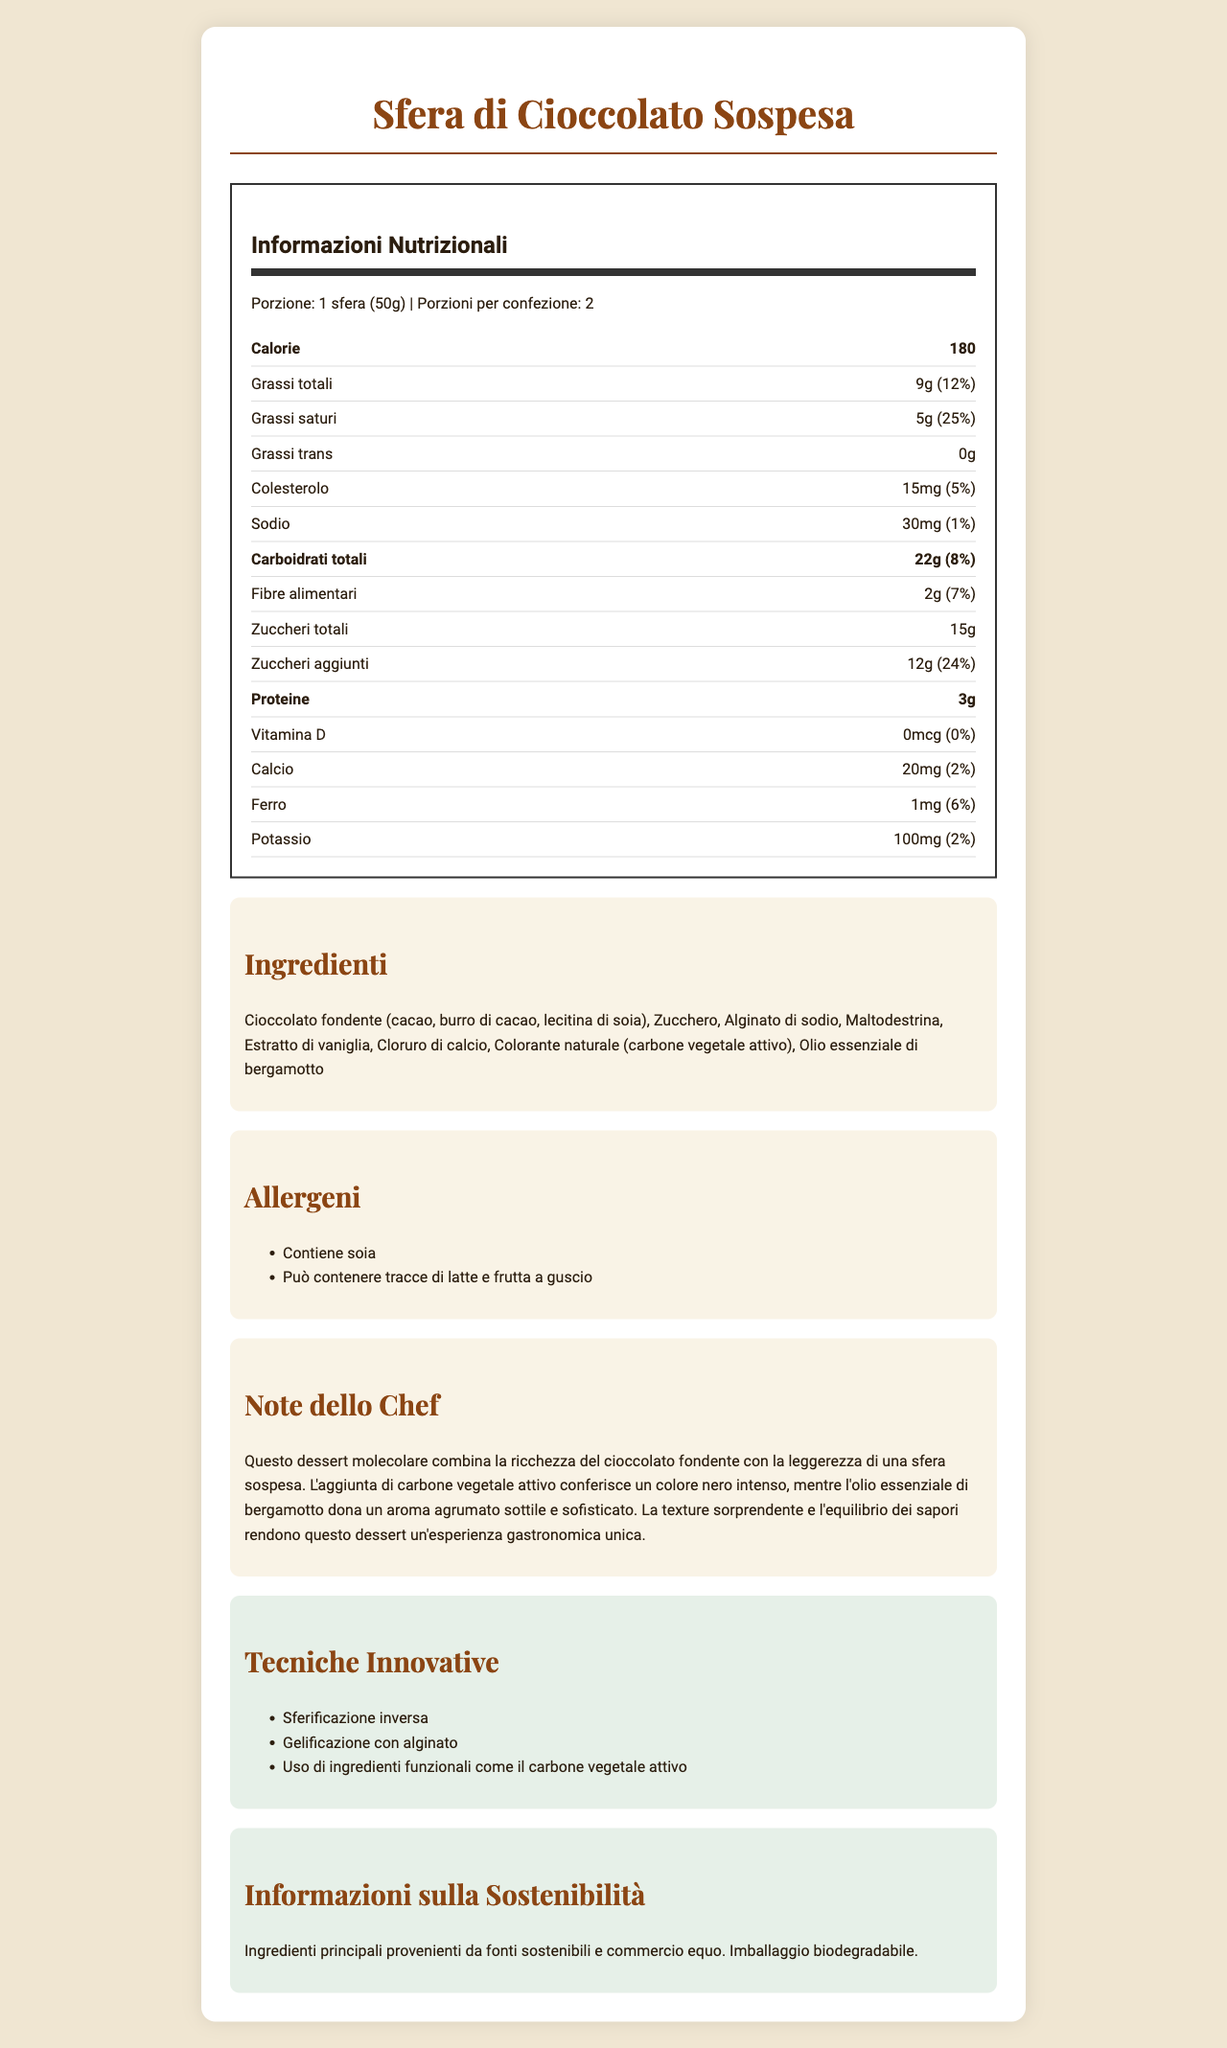what is the serving size for Sfera di Cioccolato Sospesa? The serving size is clearly specified in the nutrition label under the section with the title "Informazioni Nutrizionali".
Answer: 1 sfera (50g) how many servings are in one container? The document states "Porzioni per confezione: 2" in the nutrition information section.
Answer: 2 what is the total amount of calories per serving? The calories per serving are listed as "Calorie 180" in the nutrition label.
Answer: 180 calories what percentage of the daily value of saturated fat does one serving contain? Under the "Grassi saturi" section, it states "5g (25%)" indicating the daily value percentage.
Answer: 25% what innovative techniques are used in the creation of this dessert? The innovative techniques are listed under the "Tecniche Innovative" section.
Answer: Sferificazione inversa, Gelificazione con alginato, Uso di ingredienti funzionali come il carbone vegetale attivo which ingredient is responsible for the black color of the dessert? A. Cioccolato fondente B. Carbone vegetale attivo C. Alginato di sodio D. Maltodestrina The chef's notes mention that the "carbone vegetale attivo" gives an intense black color.
Answer: B what allergens are present in the dessert? The allergens are clearly listed under the "Allergeni" section.
Answer: Contiene soia, Può contenere tracce di latte e frutta a guscio is there any trans fat in this dessert? The nutrition label under the "Grassi trans" section indicates "0g".
Answer: No how much calcium does one serving provide? The amount of calcium is found in the nutrition label under the section "Calcio", specifying "20mg (2%)".
Answer: 20 mg summarize the key aspects of this dessert. This summary captures the main content of the document which includes the name and type of dessert, its unique features, innovative techniques, ingredients, nutritional facts, sustainability information, and allergens.
Answer: Sfera di Cioccolato Sospesa is a molecular dessert that features a rich dark chocolate sphere suspended using molecular gastronomy techniques like inverse spherification and alginate gelling. It integrates innovative ingredients like activated charcoal for a striking black color and bergamot essential oil for a subtle citrus aroma. It contains 180 calories per serving with nutritional information outlined for fats, carbohydrates, and proteins. It is also sustainably sourced and packaged. Allergens include soy, and it may contain traces of milk and nuts. how much protein does one serving contain? The nutrition label under "Proteine" indicates "3g".
Answer: 3 grams does this dessert contain dietary fiber? A. Yes, 2g per serving B. No, 0g per serving C. Yes, 5g per serving D. No, 3g per serving The nutrition label specifies the dietary fiber content as "2g (7%)".
Answer: A what is the total carbohydrate content per serving? The total carbohydrate content is provided in the nutrition label as "Carboidrati totali 22g (8%)".
Answer: 22 grams can the source of the essential oils used in this dessert be determined from the document? The document states the use of "Olio essenziale di bergamotto" but does not mention the source of these essential oils.
Answer: Not enough information 